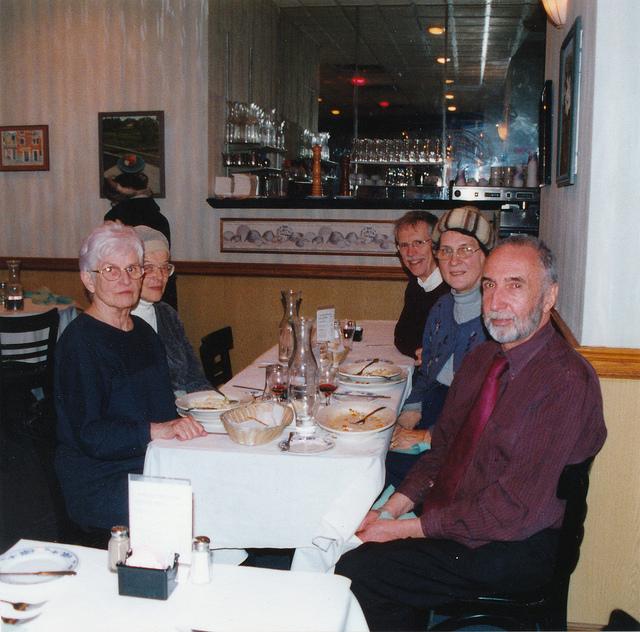How many people are looking at the camera?
Short answer required. 5. What kind of food did this restaurant serve on the side?
Quick response, please. Bread. How many candles are in the picture?
Be succinct. 0. Did the people finish their food?
Quick response, please. Yes. Would this be a good location for a lunch date?
Short answer required. Yes. Are the glasses hanging upside down?
Write a very short answer. No. How many wines bottles are here?
Answer briefly. 0. What room is she in?
Answer briefly. Dining. How many people are in the photo?
Concise answer only. 6. Does every plate have an owner?
Keep it brief. Yes. Does this look like a military event?
Give a very brief answer. No. Is there anything in the bowl on the table?
Be succinct. Yes. How many men are at the table?
Answer briefly. 2. Did the guy with the red tie get a present?
Concise answer only. No. What is the man doing?
Write a very short answer. Sitting. Are there any greeting cards on the table?
Concise answer only. No. Did everyone contribute food?
Answer briefly. No. What color are the napkins?
Be succinct. White. 